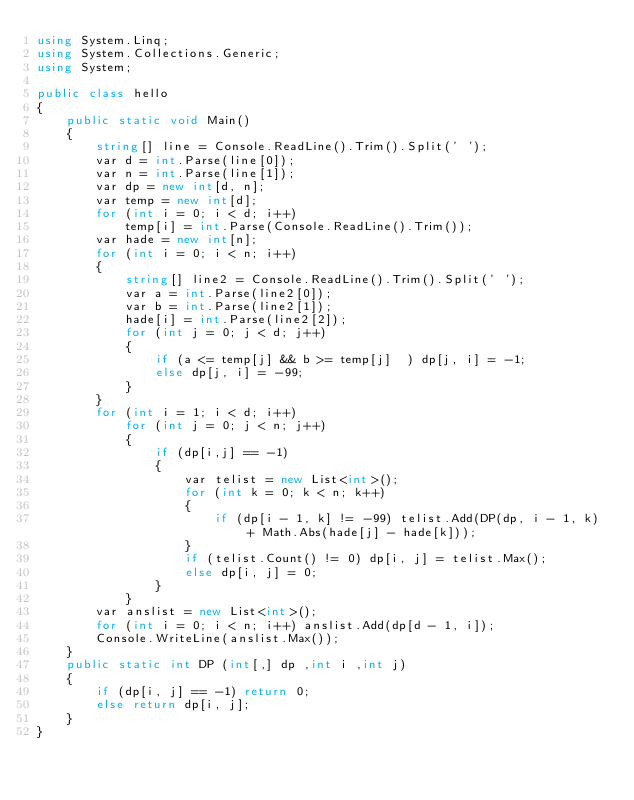<code> <loc_0><loc_0><loc_500><loc_500><_C#_>using System.Linq;
using System.Collections.Generic;
using System;

public class hello
{
    public static void Main()
    {
        string[] line = Console.ReadLine().Trim().Split(' ');
        var d = int.Parse(line[0]);
        var n = int.Parse(line[1]);
        var dp = new int[d, n];
        var temp = new int[d];
        for (int i = 0; i < d; i++)
            temp[i] = int.Parse(Console.ReadLine().Trim());
        var hade = new int[n];
        for (int i = 0; i < n; i++)
        {
            string[] line2 = Console.ReadLine().Trim().Split(' ');
            var a = int.Parse(line2[0]);
            var b = int.Parse(line2[1]);
            hade[i] = int.Parse(line2[2]);
            for (int j = 0; j < d; j++)
            {
                if (a <= temp[j] && b >= temp[j]  ) dp[j, i] = -1;
                else dp[j, i] = -99;
            }
        }
        for (int i = 1; i < d; i++)
            for (int j = 0; j < n; j++)
            {
                if (dp[i,j] == -1)
                {
                    var telist = new List<int>();
                    for (int k = 0; k < n; k++)
                    {
                        if (dp[i - 1, k] != -99) telist.Add(DP(dp, i - 1, k) + Math.Abs(hade[j] - hade[k]));
                    }
                    if (telist.Count() != 0) dp[i, j] = telist.Max();
                    else dp[i, j] = 0;
                }
            }
        var anslist = new List<int>();
        for (int i = 0; i < n; i++) anslist.Add(dp[d - 1, i]);
        Console.WriteLine(anslist.Max());
    }
    public static int DP (int[,] dp ,int i ,int j)
    {
        if (dp[i, j] == -1) return 0;
        else return dp[i, j];
    }
}</code> 